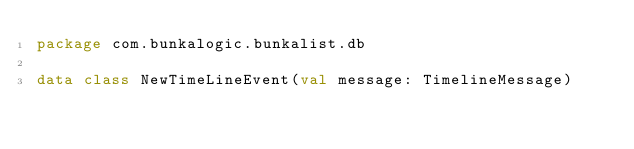<code> <loc_0><loc_0><loc_500><loc_500><_Kotlin_>package com.bunkalogic.bunkalist.db

data class NewTimeLineEvent(val message: TimelineMessage)</code> 